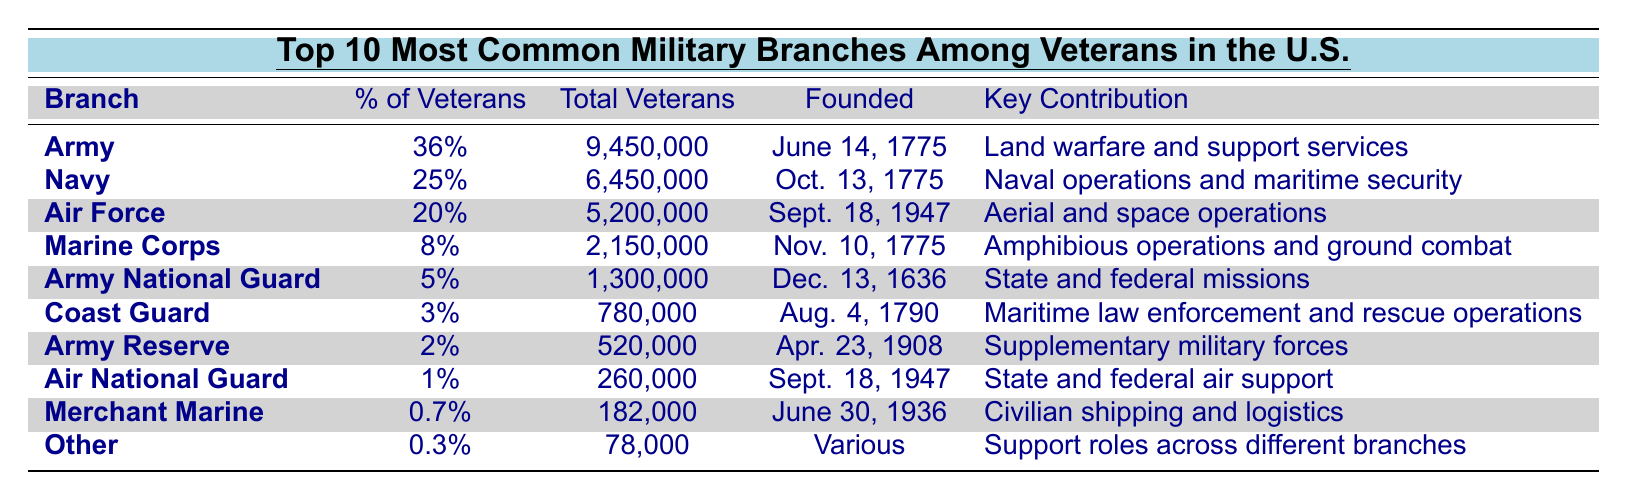What is the most common military branch among veterans in the U.S.? The table shows that the Army has the highest percentage of veterans at 36%.
Answer: Army How many total veterans served in the Navy? According to the table, the total number of veterans who served in the Navy is 6,450,000.
Answer: 6,450,000 What is the key contribution of the Marine Corps? The table indicates that the Marine Corps' key contribution is amphibious operations and ground combat.
Answer: Amphibious operations and ground combat Which military branch was founded first? The Army was founded on June 14, 1775, which is earlier than any other branch listed in the table.
Answer: Army How many veterans are there in the Coast Guard? The table states that there are 780,000 veterans in the Coast Guard.
Answer: 780,000 What percentage of veterans served in the Army Reserve? The Army Reserve comprises 2% of the total veterans according to the table.
Answer: 2% What is the difference in the number of veterans between the Air Force and the Marine Corps? The Air Force has 5,200,000 veterans and the Marine Corps has 2,150,000 veterans. The difference is 5,200,000 - 2,150,000 = 3,050,000.
Answer: 3,050,000 How many veterans served in branches with less than 5% representation? Adding the total veterans from the Army Reserve (520,000), Air National Guard (260,000), Merchant Marine (182,000), and Other (78,000) gives 1,040,000.
Answer: 1,040,000 Is it true that the Air National Guard has contributed to state and federal air support? The table lists the Air National Guard's key contribution as state and federal air support, confirming that statement is true.
Answer: True Which branches have a total veteran count less than 1 million? The Coast Guard (780,000), Army Reserve (520,000), Air National Guard (260,000), Merchant Marine (182,000), and Other (78,000) all have total veteran counts below 1 million, indicating these branches are smaller in veteran numbers.
Answer: Coast Guard, Army Reserve, Air National Guard, Merchant Marine, Other If you combine the total veterans from the Navy and Air Force, how many would that be? The total from Navy (6,450,000) and Air Force (5,200,000) is 6,450,000 + 5,200,000 = 11,650,000.
Answer: 11,650,000 